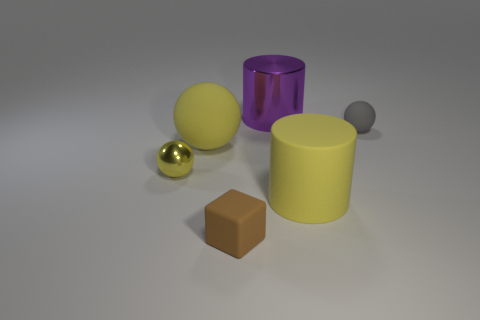What material is the other small thing that is the same shape as the gray matte object?
Your answer should be compact. Metal. There is a big thing that is to the right of the block and in front of the large purple shiny cylinder; what is its color?
Keep it short and to the point. Yellow. What is the big yellow sphere that is on the left side of the purple shiny thing made of?
Provide a short and direct response. Rubber. The gray rubber ball has what size?
Offer a very short reply. Small. How many yellow objects are metal balls or big objects?
Keep it short and to the point. 3. There is a yellow matte object that is behind the yellow thing on the left side of the big rubber sphere; what size is it?
Keep it short and to the point. Large. Do the tiny matte cube and the tiny sphere that is behind the yellow metal object have the same color?
Your response must be concise. No. How many other objects are the same material as the gray ball?
Make the answer very short. 3. What shape is the small brown thing that is made of the same material as the yellow cylinder?
Keep it short and to the point. Cube. Is there any other thing that has the same color as the cube?
Make the answer very short. No. 